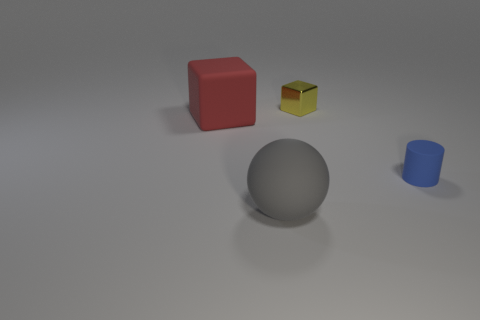Add 1 large blue cylinders. How many objects exist? 5 Subtract all cylinders. How many objects are left? 3 Add 1 small blue matte objects. How many small blue matte objects are left? 2 Add 3 large matte cubes. How many large matte cubes exist? 4 Subtract 0 gray cylinders. How many objects are left? 4 Subtract all small yellow things. Subtract all large green blocks. How many objects are left? 3 